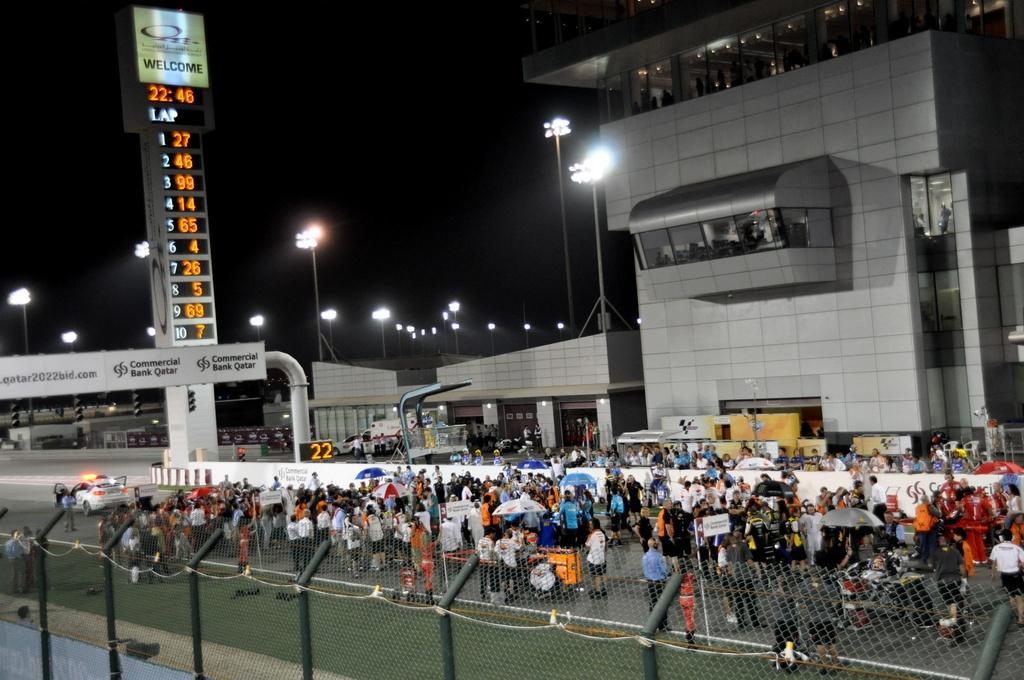Please provide a concise description of this image. As we can see in the image there is fence, group of people, banner, buildings, street lamps and sky. 